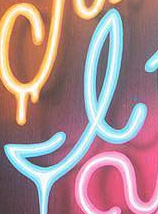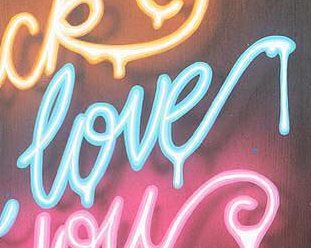What words can you see in these images in sequence, separated by a semicolon? I; love 